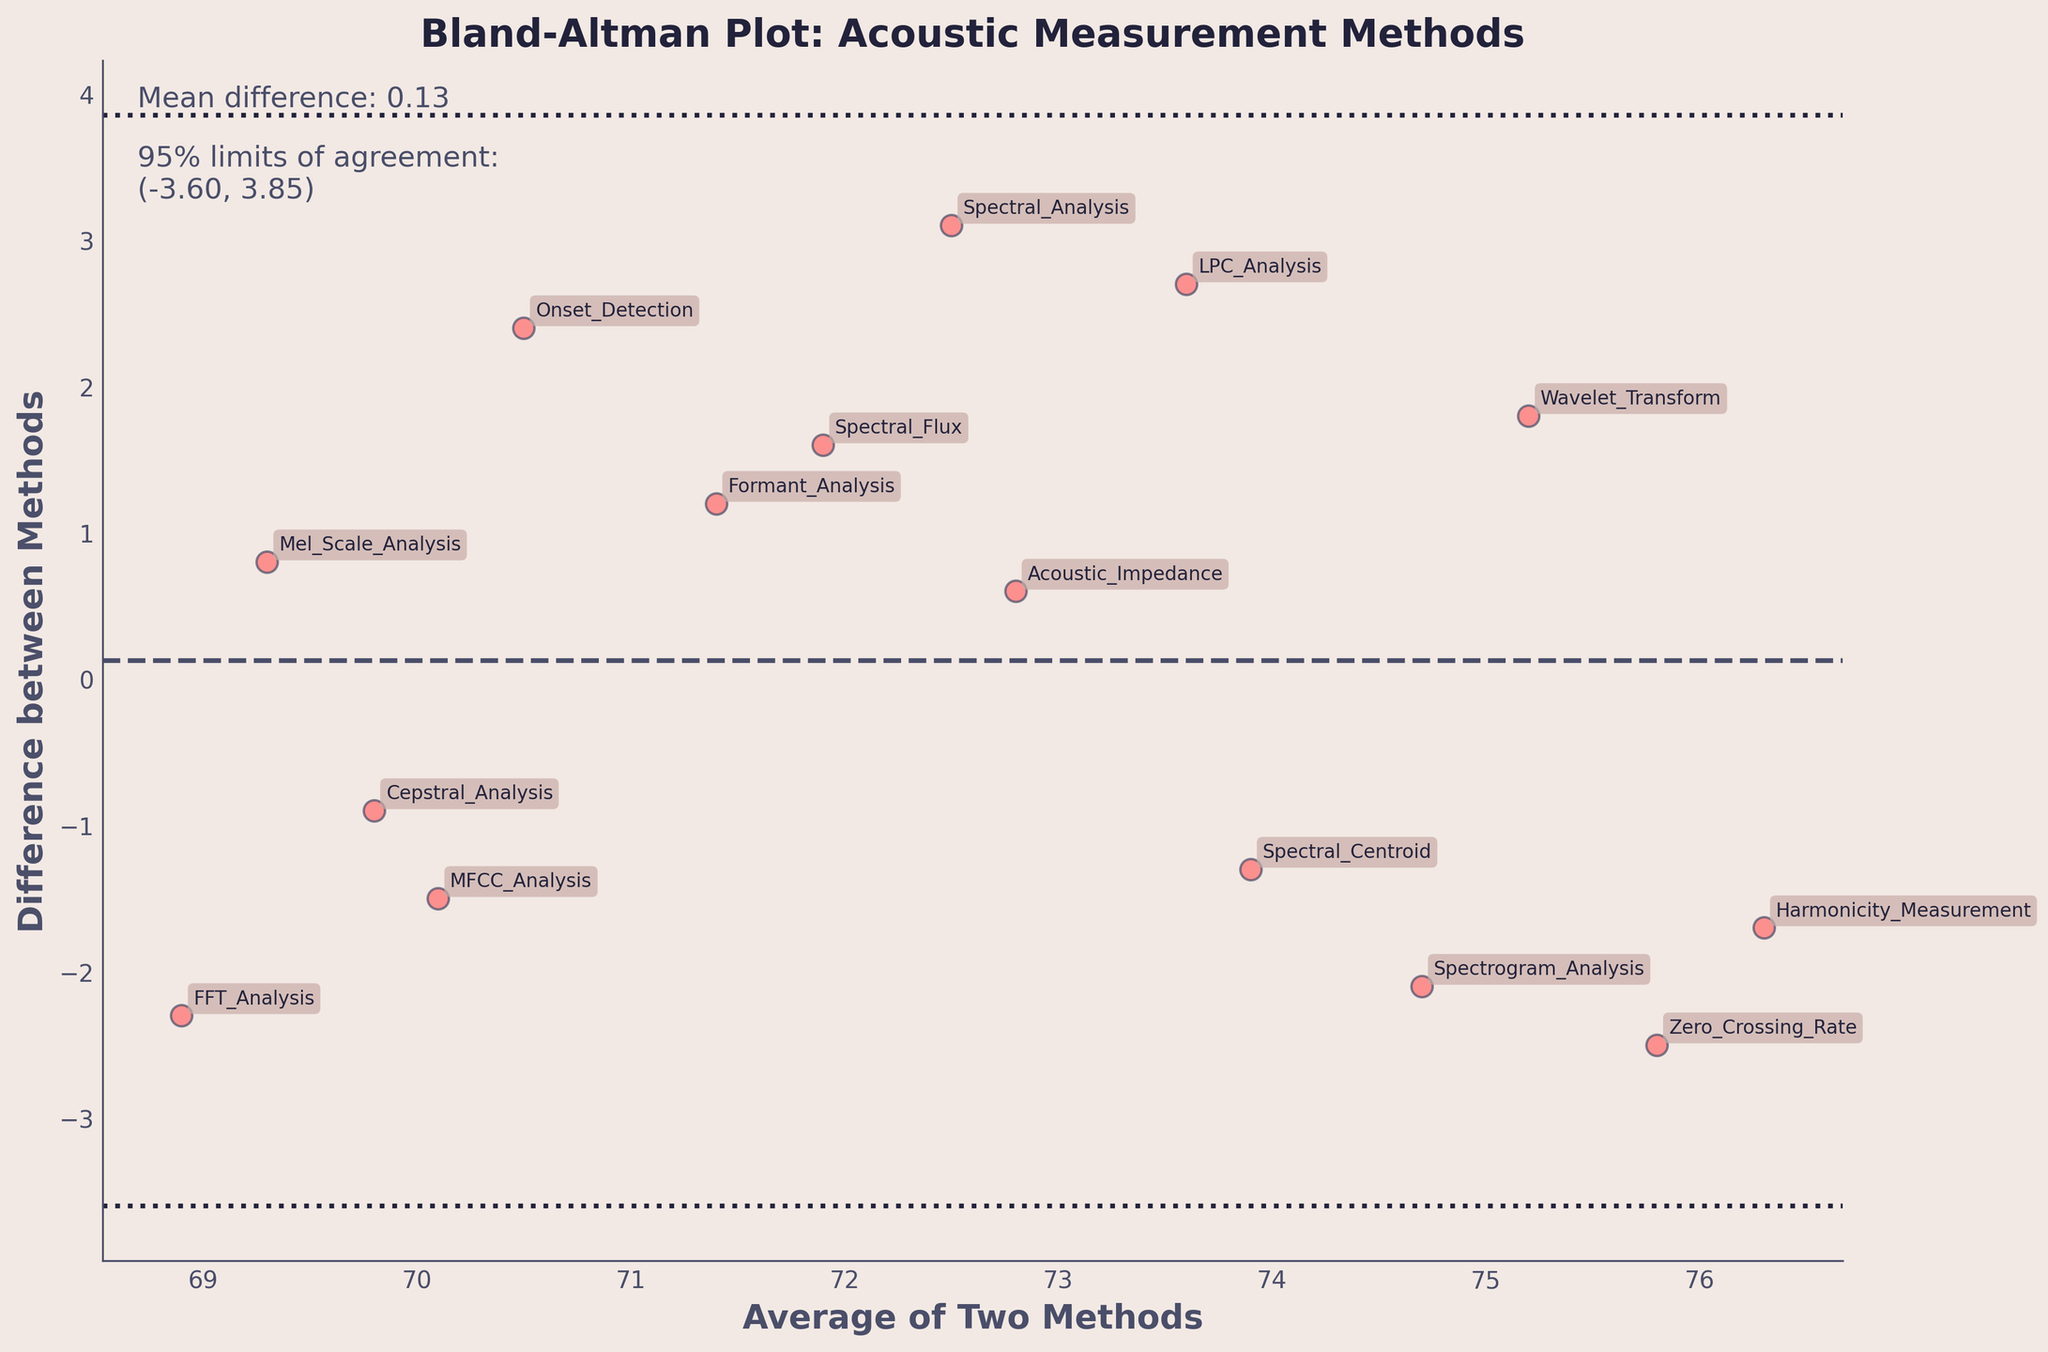what is the title of the plot? The title is typically located at the top of the plot and is plainly written. In this case, it is "Bland-Altman Plot: Acoustic Measurement Methods."
Answer: Bland-Altman Plot: Acoustic Measurement Methods How many data points are there in the plot? To find the number of data points, we count the number of individual markers or annotations in the plot. Each represents a specific measurement method comparison. Here, there appear to be 15 markers/annotations.
Answer: 15 What is the mean difference value? The mean difference value is typically indicated on the plot, often as a horizontal line. The text annotation in the plot confirms it is 0.33.
Answer: 0.33 What are the 95% limits of agreement? The limits of agreement are usually indicated by two dotted horizontal lines above and below the mean difference line. The plot annotations state these limits are (-2.92, 3.58).
Answer: (-2.92, 3.58) which acoustic measurement methods have the largest positive difference? To determine this, observe the data point that is furthest above the horizontal line of the mean difference. According to the plot data, "Spectral Analysis vs. Listening Test" with a difference of 3.1 is the highest positive difference.
Answer: Spectral Analysis vs. Listening Test Which method pair has the least negative difference? To decide this, notice the data point closest to the horizontal line of the mean difference but below it. "Cepstral Analysis vs. Resonance Measurement" has the least negative difference of -0.9.
Answer: Cepstral Analysis vs. Resonance Measurement Is there a trend visible in the differences with respect to the averages? A trend would imply that the differences systematically increase or decrease with increasing averages. Observing the scatter plot, there doesn't appear to be any upward or downward trend in the differences relative to the averages; the points seem randomly scattered.
Answer: No Are most of the differences within the 95% limits of agreement? By checking the plot visually, most of the data points appear to fall between the two dotted horizontal lines, indicating they are within the 95% limits of agreement.
Answer: Yes Which axes are labeled in the plot, and what are the labels? Axes labels are typically placed at the ends of the axes. For this plot, the x-axis is labeled "Average of Two Methods" and the y-axis is labeled "Difference between Methods."
Answer: Average of Two Methods (x-axis), Difference between Methods (y-axis) What is the color of the points in the plot? Observing the color of the scatter points, we can see they are shaded in a vibrant shade of red.
Answer: Red 